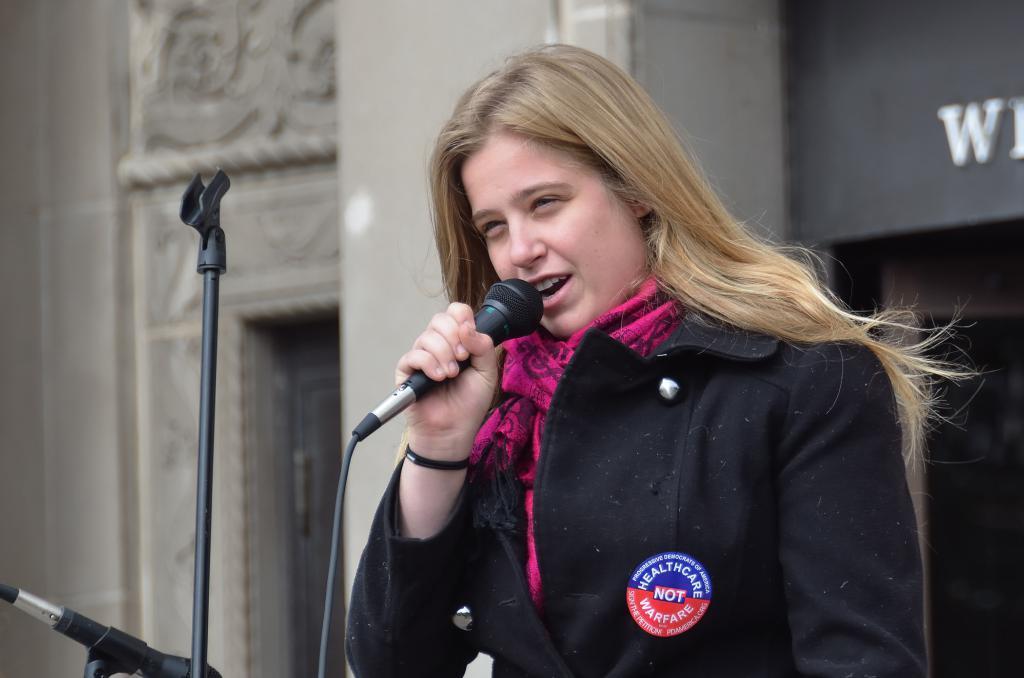How would you summarize this image in a sentence or two? Here we can see a woman speaking something in the microphone present in her hand and there is a stand present in front of her 